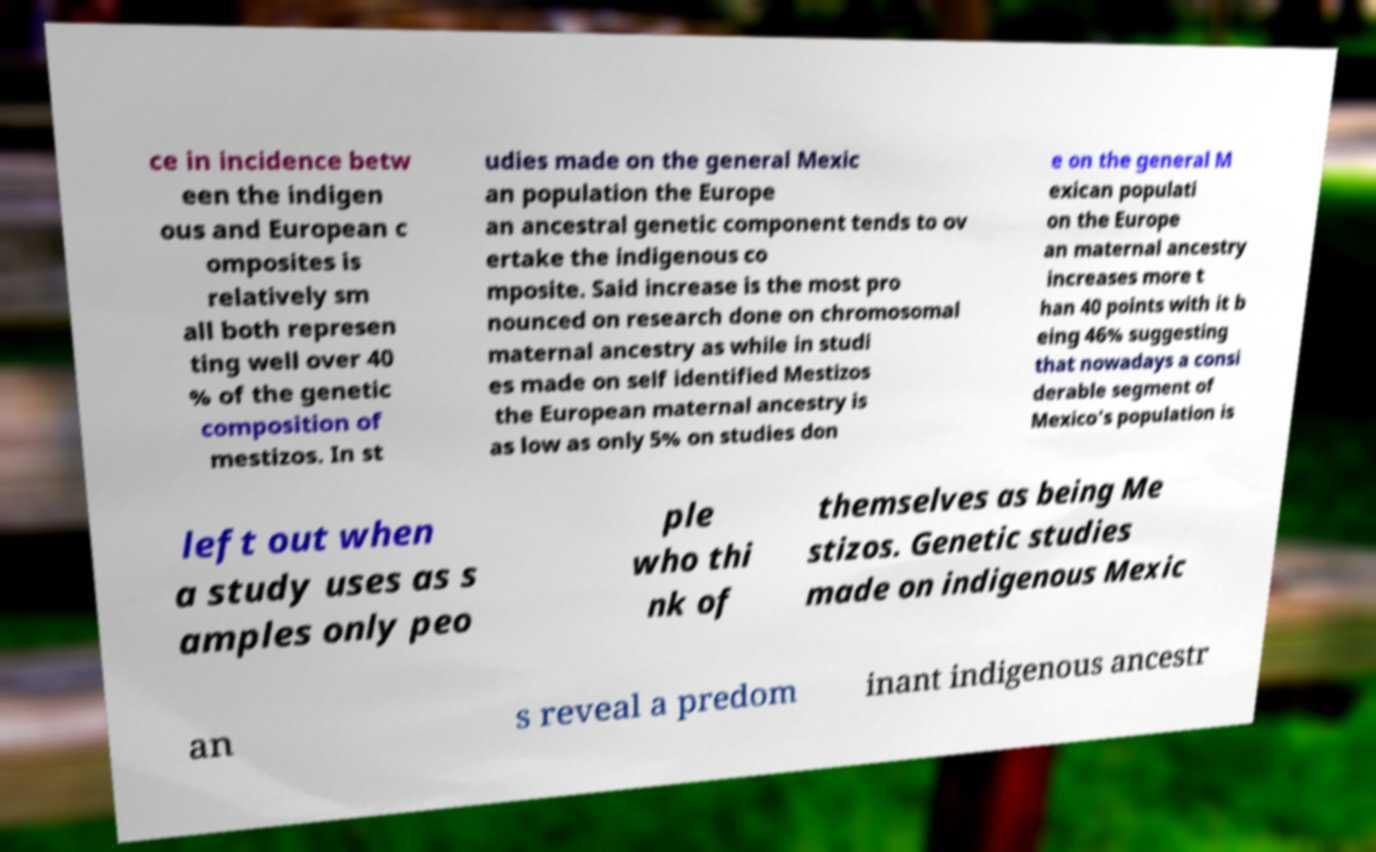What messages or text are displayed in this image? I need them in a readable, typed format. ce in incidence betw een the indigen ous and European c omposites is relatively sm all both represen ting well over 40 % of the genetic composition of mestizos. In st udies made on the general Mexic an population the Europe an ancestral genetic component tends to ov ertake the indigenous co mposite. Said increase is the most pro nounced on research done on chromosomal maternal ancestry as while in studi es made on self identified Mestizos the European maternal ancestry is as low as only 5% on studies don e on the general M exican populati on the Europe an maternal ancestry increases more t han 40 points with it b eing 46% suggesting that nowadays a consi derable segment of Mexico's population is left out when a study uses as s amples only peo ple who thi nk of themselves as being Me stizos. Genetic studies made on indigenous Mexic an s reveal a predom inant indigenous ancestr 